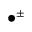<formula> <loc_0><loc_0><loc_500><loc_500>\bullet ^ { \pm }</formula> 